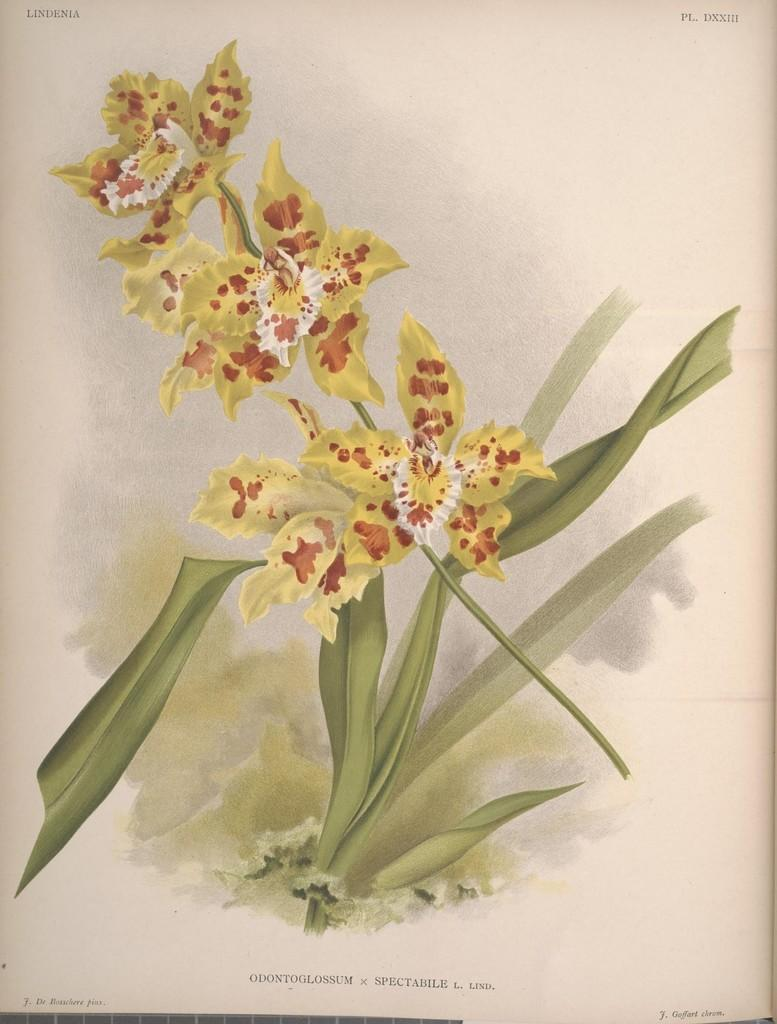What is depicted on the poster in the image? The poster contains flowers with stems and leaves. Where is the text located on the poster? There is text at the top and bottom of the image. What type of juice is being poured from the whistle in the image? There is no juice or whistle present in the image; it only features a poster with flowers and text. 